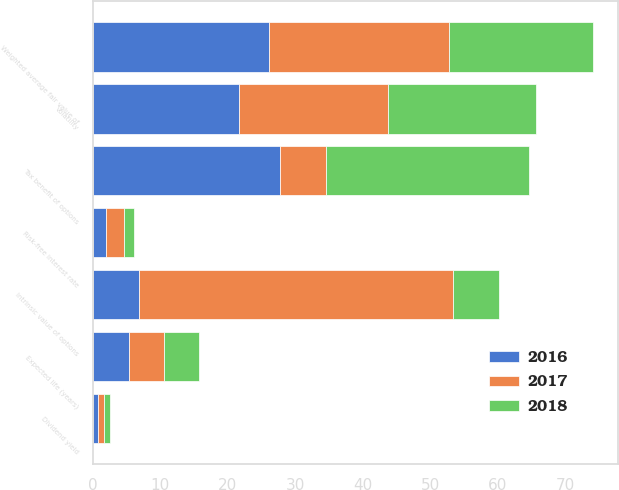<chart> <loc_0><loc_0><loc_500><loc_500><stacked_bar_chart><ecel><fcel>Dividend yield<fcel>Volatility<fcel>Risk-free interest rate<fcel>Expected life (years)<fcel>Weighted average fair value of<fcel>Intrinsic value of options<fcel>Tax benefit of options<nl><fcel>2017<fcel>0.8<fcel>22.1<fcel>2.7<fcel>5.2<fcel>26.66<fcel>46.6<fcel>6.8<nl><fcel>2016<fcel>0.8<fcel>21.6<fcel>2<fcel>5.3<fcel>26.09<fcel>6.8<fcel>27.7<nl><fcel>2018<fcel>0.9<fcel>21.9<fcel>1.4<fcel>5.3<fcel>21.3<fcel>6.8<fcel>30.1<nl></chart> 